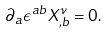<formula> <loc_0><loc_0><loc_500><loc_500>\partial _ { a } \epsilon ^ { a b } X ^ { \nu } _ { , b } = 0 .</formula> 